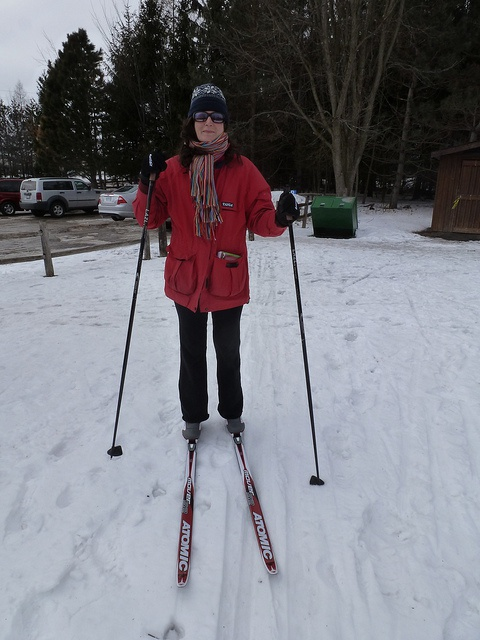Describe the objects in this image and their specific colors. I can see people in lightgray, maroon, black, gray, and brown tones, skis in lightgray, darkgray, maroon, gray, and black tones, truck in lightgray, black, gray, and darkgray tones, car in lightgray, black, gray, and darkgray tones, and car in lightgray, gray, darkgray, and black tones in this image. 